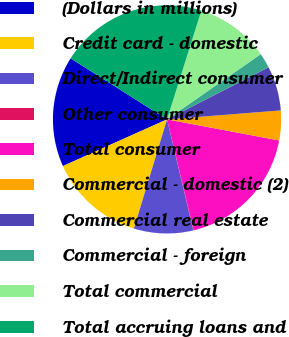Convert chart. <chart><loc_0><loc_0><loc_500><loc_500><pie_chart><fcel>(Dollars in millions)<fcel>Credit card - domestic<fcel>Direct/Indirect consumer<fcel>Other consumer<fcel>Total consumer<fcel>Commercial - domestic (2)<fcel>Commercial real estate<fcel>Commercial - foreign<fcel>Total commercial<fcel>Total accruing loans and<nl><fcel>15.69%<fcel>13.6%<fcel>8.38%<fcel>0.05%<fcel>18.3%<fcel>4.21%<fcel>6.3%<fcel>2.13%<fcel>10.46%<fcel>20.88%<nl></chart> 